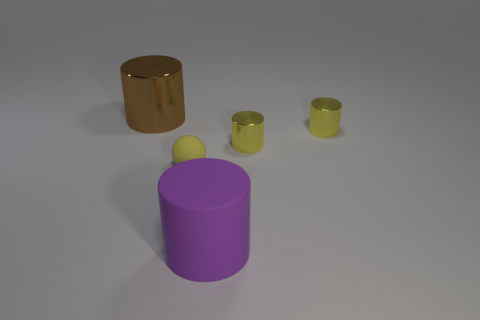Subtract 1 cylinders. How many cylinders are left? 3 Add 3 big brown cylinders. How many objects exist? 8 Subtract all cylinders. How many objects are left? 1 Subtract all small yellow objects. Subtract all large rubber cylinders. How many objects are left? 1 Add 4 shiny cylinders. How many shiny cylinders are left? 7 Add 2 yellow metal objects. How many yellow metal objects exist? 4 Subtract 0 gray cylinders. How many objects are left? 5 